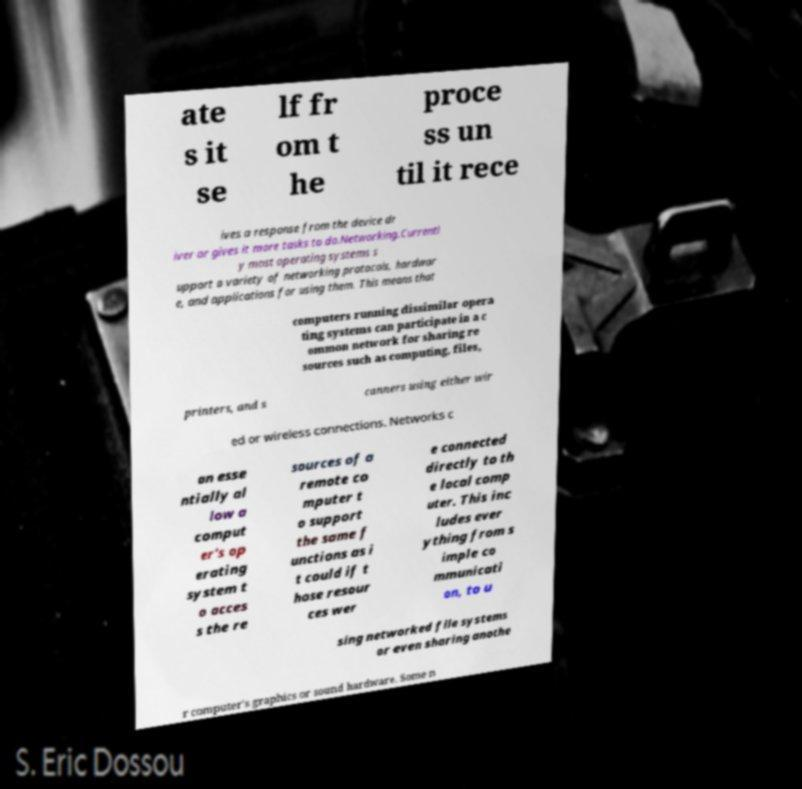I need the written content from this picture converted into text. Can you do that? ate s it se lf fr om t he proce ss un til it rece ives a response from the device dr iver or gives it more tasks to do.Networking.Currentl y most operating systems s upport a variety of networking protocols, hardwar e, and applications for using them. This means that computers running dissimilar opera ting systems can participate in a c ommon network for sharing re sources such as computing, files, printers, and s canners using either wir ed or wireless connections. Networks c an esse ntially al low a comput er's op erating system t o acces s the re sources of a remote co mputer t o support the same f unctions as i t could if t hose resour ces wer e connected directly to th e local comp uter. This inc ludes ever ything from s imple co mmunicati on, to u sing networked file systems or even sharing anothe r computer's graphics or sound hardware. Some n 